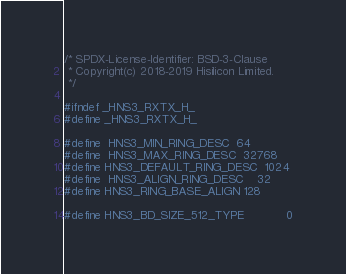Convert code to text. <code><loc_0><loc_0><loc_500><loc_500><_C_>/* SPDX-License-Identifier: BSD-3-Clause
 * Copyright(c) 2018-2019 Hisilicon Limited.
 */

#ifndef _HNS3_RXTX_H_
#define _HNS3_RXTX_H_

#define	HNS3_MIN_RING_DESC	64
#define	HNS3_MAX_RING_DESC	32768
#define HNS3_DEFAULT_RING_DESC  1024
#define	HNS3_ALIGN_RING_DESC	32
#define HNS3_RING_BASE_ALIGN	128

#define HNS3_BD_SIZE_512_TYPE			0</code> 